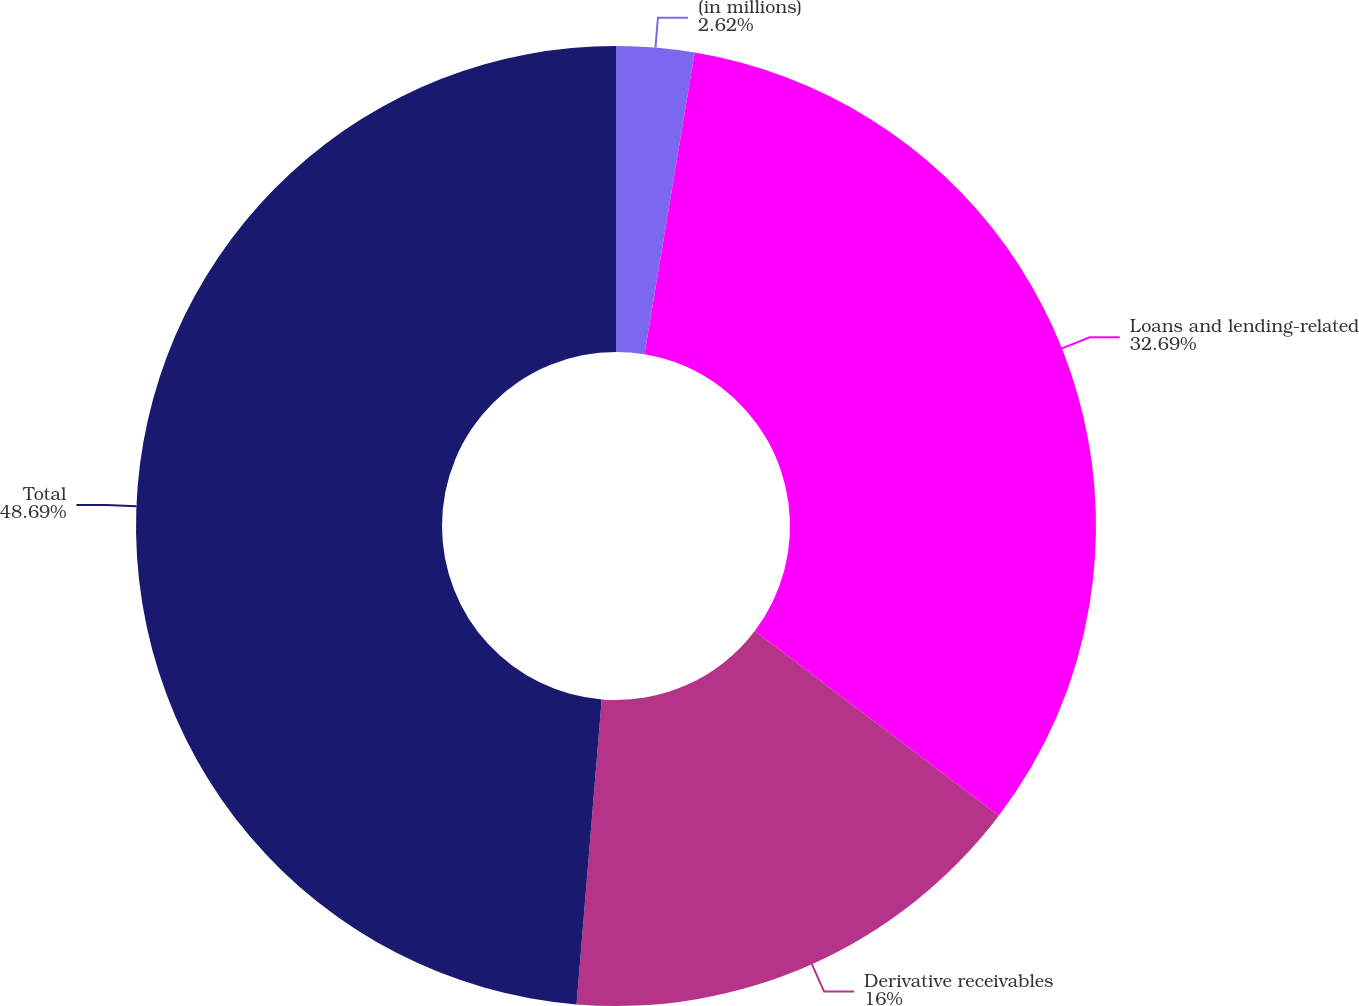Convert chart. <chart><loc_0><loc_0><loc_500><loc_500><pie_chart><fcel>(in millions)<fcel>Loans and lending-related<fcel>Derivative receivables<fcel>Total<nl><fcel>2.62%<fcel>32.69%<fcel>16.0%<fcel>48.69%<nl></chart> 